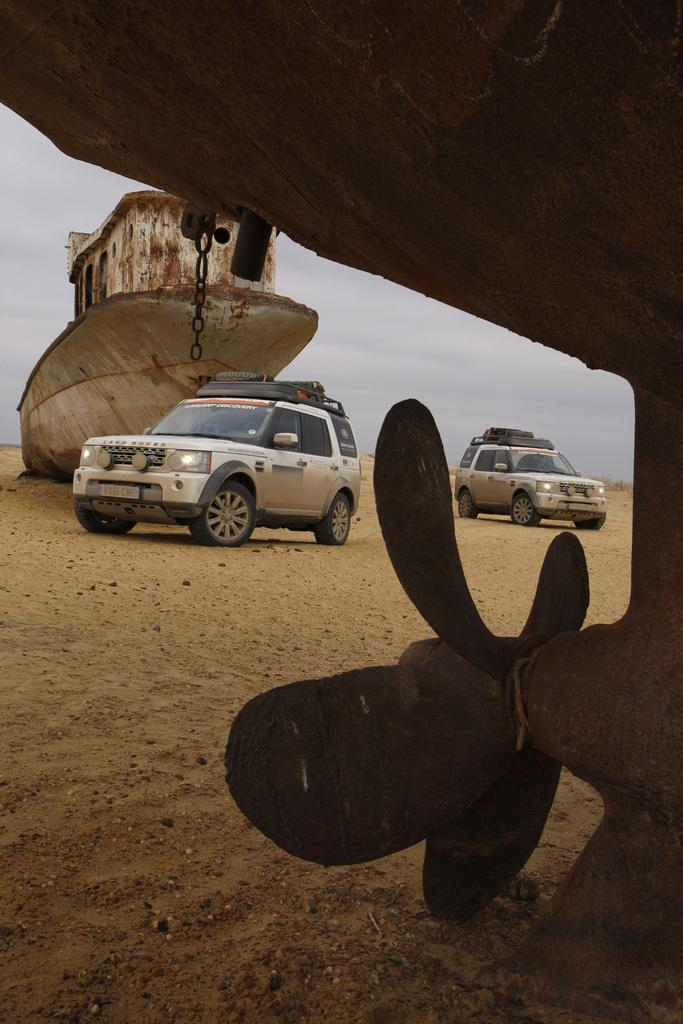How many cars are in the image? There are two cars in the image. What is the location of the cars in relation to the white ship? The cars are near a white ship in the image. What object can be seen on the right side of the image? There is a propeller fan on the right side of the image. What can be seen in the background of the image? The sky is visible in the background of the image, and there are clouds in the sky. What type of terrain is present on the right side of the image? There is sand on the right side of the image. What type of brass material is present on the passenger's seat in the image? There is no brass material or passenger's seat present in the image. What type of leather is used to cover the steering wheel of the cars in the image? There is no information about the material used for the steering wheel in the image. 